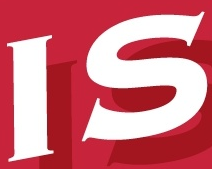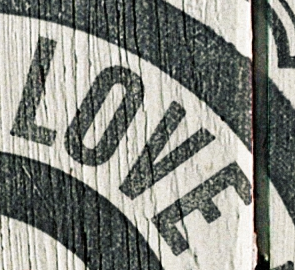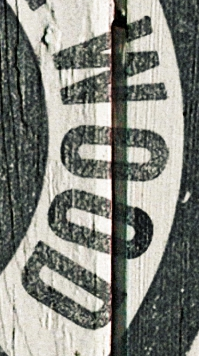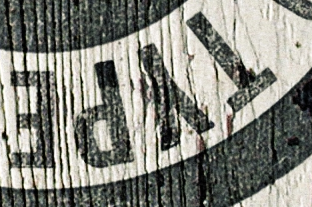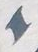What text appears in these images from left to right, separated by a semicolon? IS; LOVE; WOOD; TYPE; I 